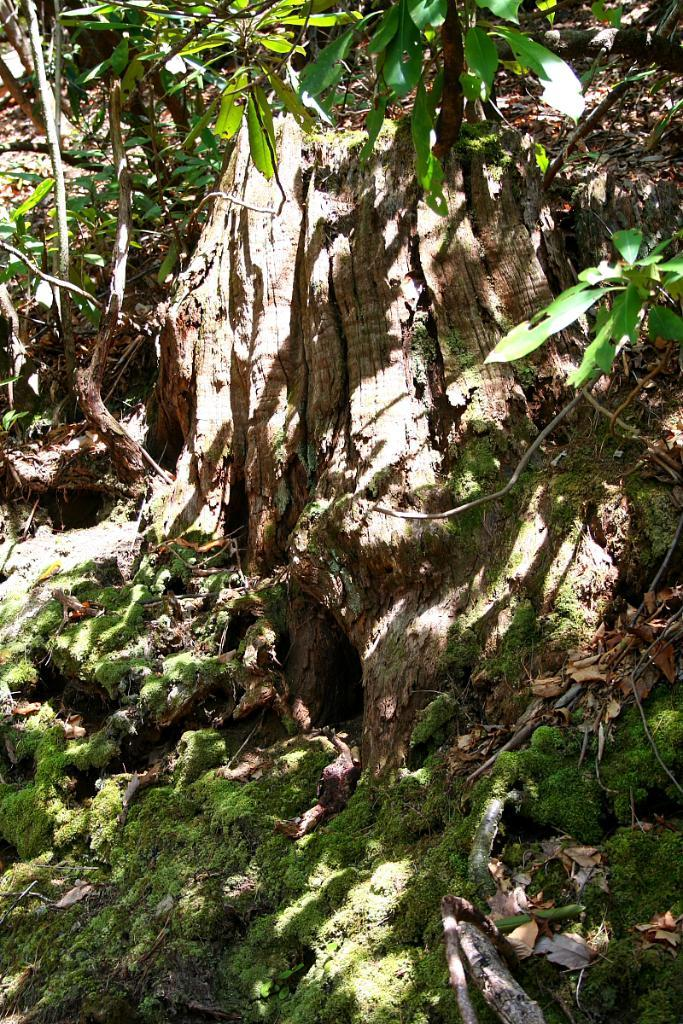What type of vegetation can be seen in the image? There is grass in the image. What else can be seen in the image besides grass? There is a branch and green leaves in the image. How does the organization of the bikes compare to the green leaves in the image? There are no bikes present in the image, so it is not possible to make a comparison between the organization of bikes and the green leaves. 